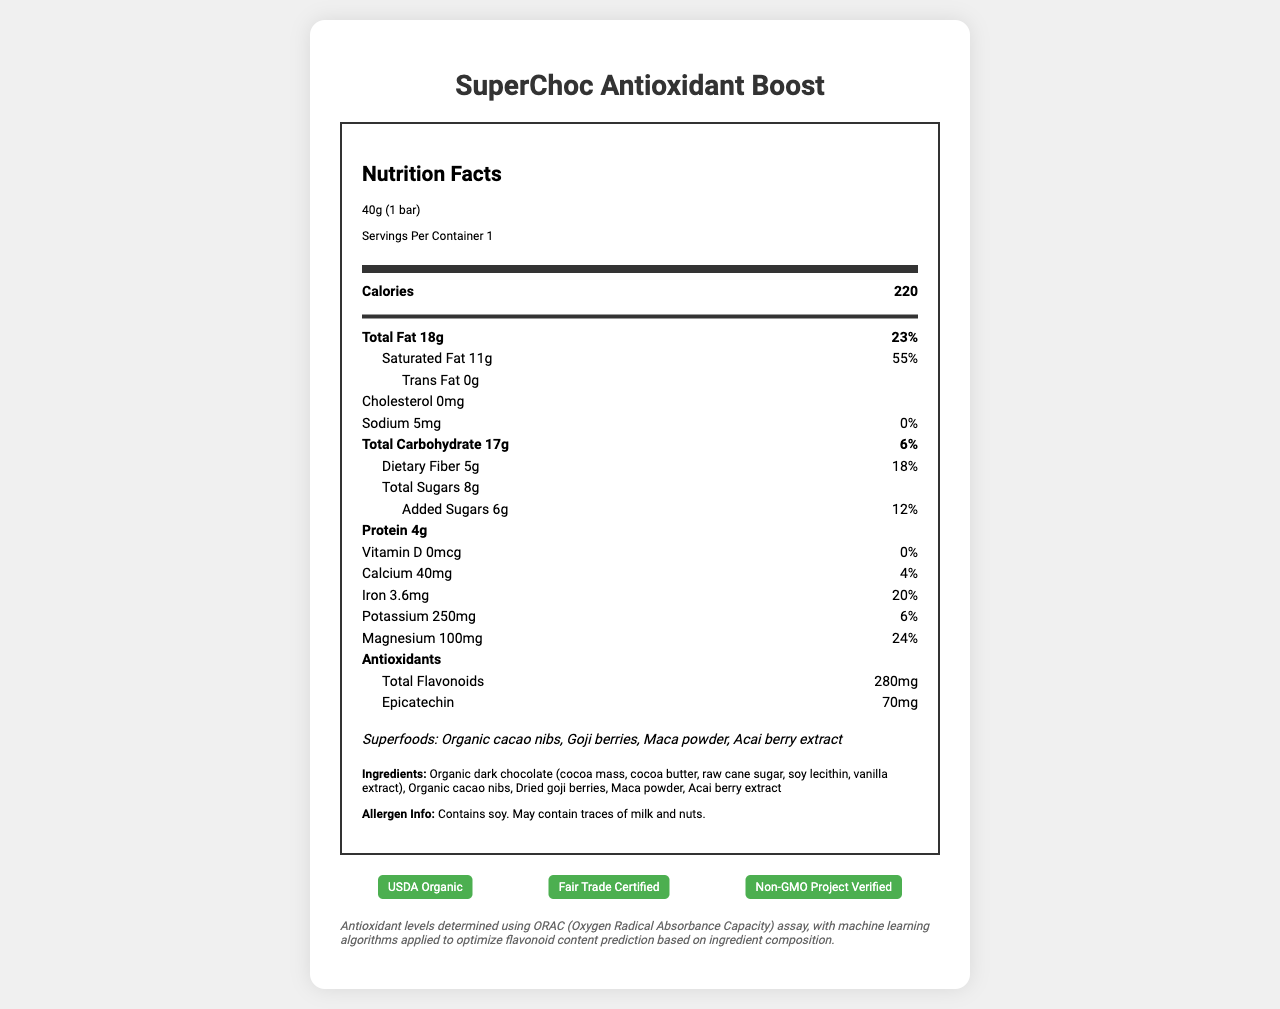what is the serving size of the gourmet dark chocolate bar? The serving size is explicitly mentioned as "40g (1 bar)" in the document.
Answer: 40g (1 bar) how many calories are in one serving of the chocolate bar? The number of calories in one serving is listed as 220.
Answer: 220 what is the total fat content per serving? The document specifies the total fat content per serving as 18g.
Answer: 18g how much sugar is added to the chocolate bar? The added sugars are explicitly noted as 6g.
Answer: 6g list the superfoods included in the chocolate bar. The superfoods are listed as Organic cacao nibs, Goji berries, Maca powder, and Acai berry extract in the document.
Answer: Organic cacao nibs, Goji berries, Maca powder, Acai berry extract what nutrients have zero daily value percentage in the chocolate bar? Both Vitamin D and Sodium have a daily value percentage of 0%.
Answer: Vitamin D, Sodium which certifications does the chocolate bar have? A. USDA Organic B. Fair Trade Certified C. Non-GMO Project Verified D. All of the above The chocolate bar has all three certifications: USDA Organic, Fair Trade Certified, and Non-GMO Project Verified.
Answer: D. All of the above which antioxidant is present at a higher amount in the bar? A. Total flavonoids B. Epicatechin Total flavonoids are present at 280mg, while Epicatechin has 70mg.
Answer: A. Total flavonoids are there any allergens in the chocolate bar? The allergen information in the document indicates that the bar contains soy and may contain traces of milk and nuts.
Answer: Yes summarize the main nutritional content and special ingredients of the SuperChoc Antioxidant Boost chocolate bar. This summary captures the bar's main nutritional data, special ingredients, antioxidants, potential allergens, and certifications.
Answer: The SuperChoc Antioxidant Boost chocolate bar contains 220 calories per 40g serving, with significant amounts of total fat (18g) and saturated fat (11g). It boasts high levels of fiber (5g), protein (4g), and several key minerals such as calcium, iron, potassium, and magnesium. The bar is enriched with superfoods like Organic cacao nibs, Goji berries, Maca powder, and Acai berry extract. Additionally, it contains antioxidants, including total flavonoids (280mg) and Epicatechin (70mg). The bar is soy-inclusive and may have traces of milk and nuts. It holds USDA Organic, Fair Trade Certified, and Non-GMO Project Verified certifications. what is the machine learning algorithm used for? The document refers to machine learning algorithms being used to optimize flavonoid content prediction based on ingredient composition but does not provide specific details about the algorithm used.
Answer: Not enough information 